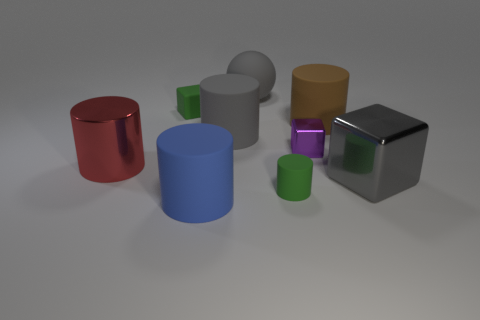Subtract all metallic cylinders. How many cylinders are left? 4 Subtract all brown cylinders. How many cylinders are left? 4 Subtract 1 cylinders. How many cylinders are left? 4 Add 1 big gray balls. How many objects exist? 10 Subtract all red cylinders. Subtract all cyan blocks. How many cylinders are left? 4 Subtract 1 red cylinders. How many objects are left? 8 Subtract all blocks. How many objects are left? 6 Subtract all purple cylinders. Subtract all brown matte cylinders. How many objects are left? 8 Add 6 gray shiny cubes. How many gray shiny cubes are left? 7 Add 5 large rubber cylinders. How many large rubber cylinders exist? 8 